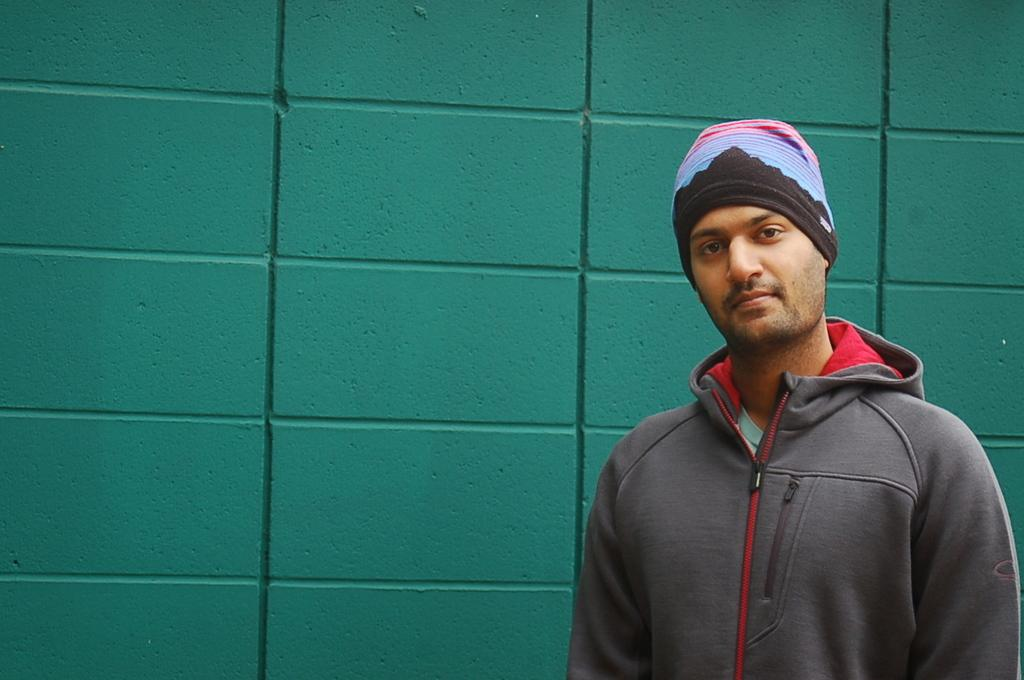Where is the man located in the image? The man is standing in the bottom right corner of the image. What is behind the man in the background of the image? There is a wall behind the man. What type of oven is visible in the image? There is no oven present in the image. 